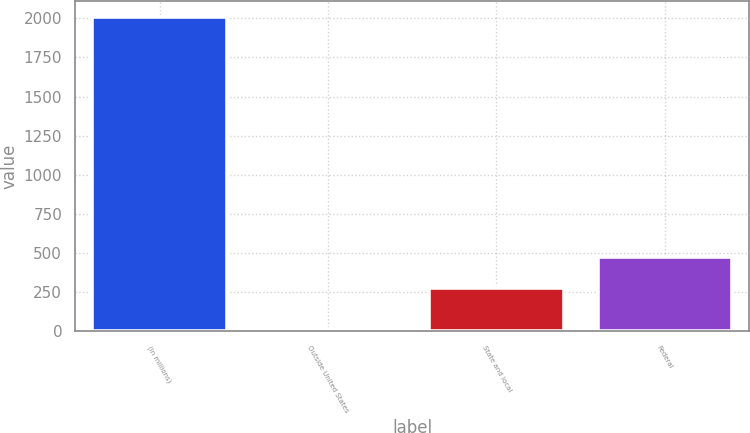Convert chart to OTSL. <chart><loc_0><loc_0><loc_500><loc_500><bar_chart><fcel>(in millions)<fcel>Outside United States<fcel>State and local<fcel>Federal<nl><fcel>2011<fcel>14<fcel>275<fcel>474.7<nl></chart> 